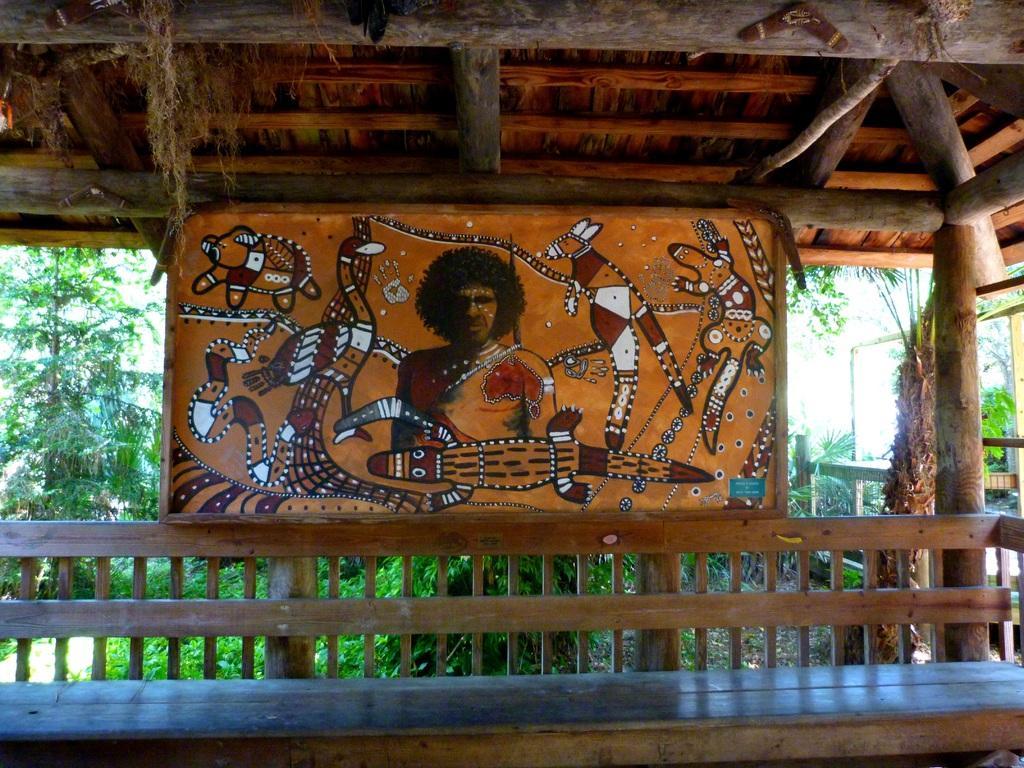Please provide a concise description of this image. In this image I can see a board, wooden bench and trees. I can see the wooden house. 